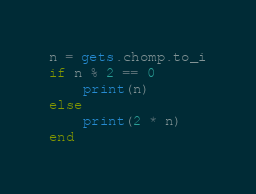<code> <loc_0><loc_0><loc_500><loc_500><_Ruby_>n = gets.chomp.to_i
if n % 2 == 0
    print(n)
else
    print(2 * n)
end</code> 